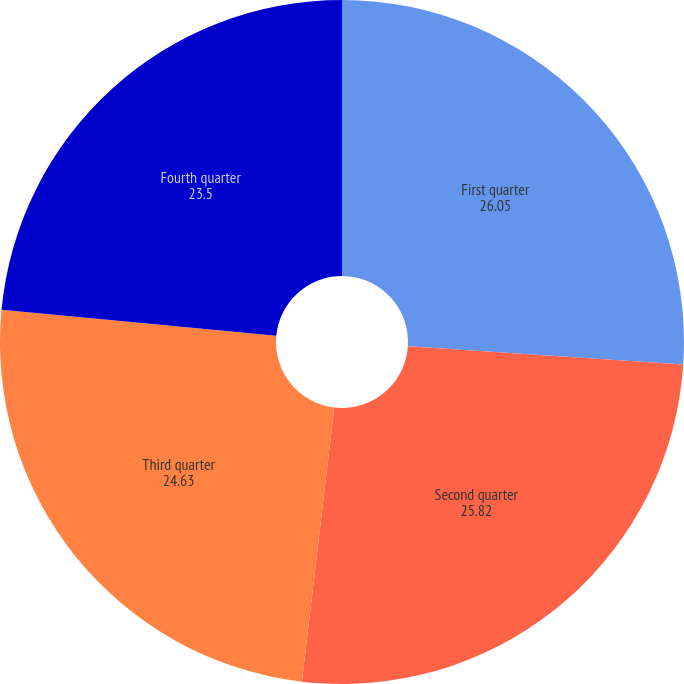Convert chart. <chart><loc_0><loc_0><loc_500><loc_500><pie_chart><fcel>First quarter<fcel>Second quarter<fcel>Third quarter<fcel>Fourth quarter<nl><fcel>26.05%<fcel>25.82%<fcel>24.63%<fcel>23.5%<nl></chart> 